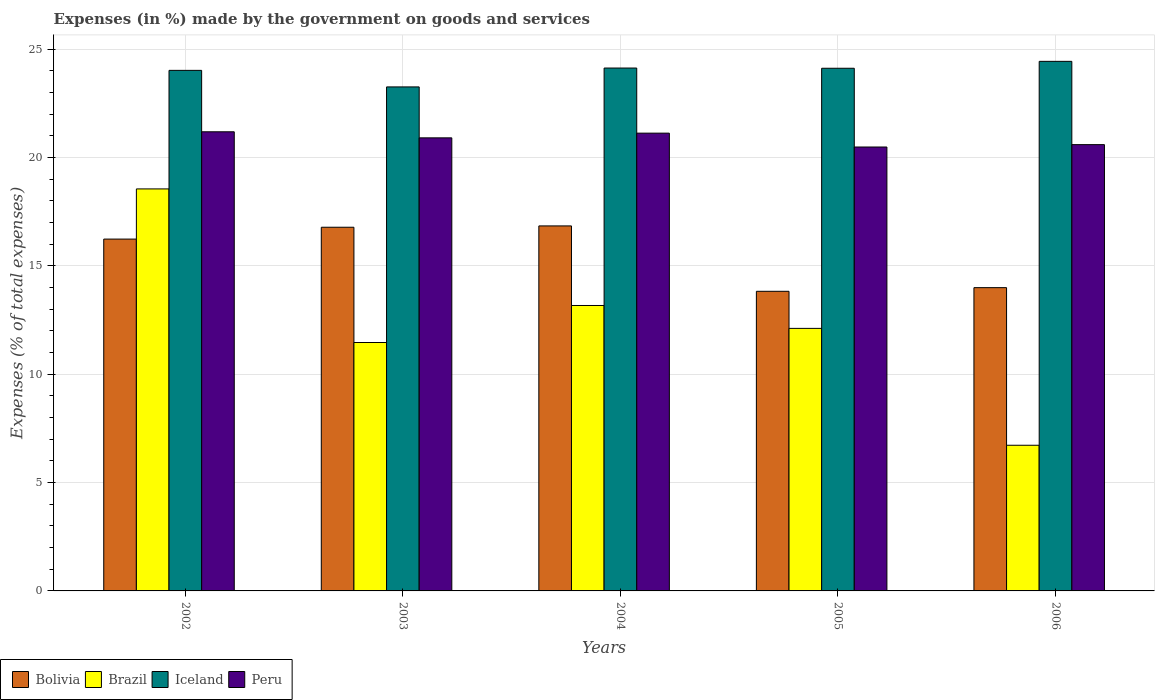Are the number of bars on each tick of the X-axis equal?
Offer a terse response. Yes. How many bars are there on the 4th tick from the left?
Your answer should be compact. 4. In how many cases, is the number of bars for a given year not equal to the number of legend labels?
Ensure brevity in your answer.  0. What is the percentage of expenses made by the government on goods and services in Bolivia in 2003?
Your answer should be very brief. 16.78. Across all years, what is the maximum percentage of expenses made by the government on goods and services in Peru?
Your response must be concise. 21.18. Across all years, what is the minimum percentage of expenses made by the government on goods and services in Peru?
Your answer should be very brief. 20.48. What is the total percentage of expenses made by the government on goods and services in Iceland in the graph?
Your answer should be very brief. 119.93. What is the difference between the percentage of expenses made by the government on goods and services in Brazil in 2002 and that in 2003?
Offer a very short reply. 7.09. What is the difference between the percentage of expenses made by the government on goods and services in Brazil in 2002 and the percentage of expenses made by the government on goods and services in Bolivia in 2004?
Make the answer very short. 1.71. What is the average percentage of expenses made by the government on goods and services in Bolivia per year?
Ensure brevity in your answer.  15.53. In the year 2004, what is the difference between the percentage of expenses made by the government on goods and services in Brazil and percentage of expenses made by the government on goods and services in Bolivia?
Give a very brief answer. -3.67. In how many years, is the percentage of expenses made by the government on goods and services in Brazil greater than 19 %?
Offer a very short reply. 0. What is the ratio of the percentage of expenses made by the government on goods and services in Brazil in 2002 to that in 2006?
Provide a short and direct response. 2.76. Is the difference between the percentage of expenses made by the government on goods and services in Brazil in 2003 and 2006 greater than the difference between the percentage of expenses made by the government on goods and services in Bolivia in 2003 and 2006?
Provide a succinct answer. Yes. What is the difference between the highest and the second highest percentage of expenses made by the government on goods and services in Bolivia?
Make the answer very short. 0.06. What is the difference between the highest and the lowest percentage of expenses made by the government on goods and services in Peru?
Make the answer very short. 0.7. Is it the case that in every year, the sum of the percentage of expenses made by the government on goods and services in Iceland and percentage of expenses made by the government on goods and services in Bolivia is greater than the sum of percentage of expenses made by the government on goods and services in Brazil and percentage of expenses made by the government on goods and services in Peru?
Ensure brevity in your answer.  Yes. What does the 2nd bar from the left in 2004 represents?
Give a very brief answer. Brazil. Is it the case that in every year, the sum of the percentage of expenses made by the government on goods and services in Peru and percentage of expenses made by the government on goods and services in Brazil is greater than the percentage of expenses made by the government on goods and services in Iceland?
Give a very brief answer. Yes. How many bars are there?
Ensure brevity in your answer.  20. Are all the bars in the graph horizontal?
Offer a very short reply. No. How many years are there in the graph?
Give a very brief answer. 5. Does the graph contain any zero values?
Your answer should be compact. No. Where does the legend appear in the graph?
Your answer should be compact. Bottom left. What is the title of the graph?
Offer a terse response. Expenses (in %) made by the government on goods and services. What is the label or title of the X-axis?
Ensure brevity in your answer.  Years. What is the label or title of the Y-axis?
Provide a short and direct response. Expenses (% of total expenses). What is the Expenses (% of total expenses) in Bolivia in 2002?
Your answer should be compact. 16.23. What is the Expenses (% of total expenses) of Brazil in 2002?
Offer a very short reply. 18.55. What is the Expenses (% of total expenses) in Iceland in 2002?
Make the answer very short. 24.01. What is the Expenses (% of total expenses) of Peru in 2002?
Your answer should be compact. 21.18. What is the Expenses (% of total expenses) of Bolivia in 2003?
Your answer should be compact. 16.78. What is the Expenses (% of total expenses) in Brazil in 2003?
Make the answer very short. 11.46. What is the Expenses (% of total expenses) in Iceland in 2003?
Your answer should be compact. 23.25. What is the Expenses (% of total expenses) in Peru in 2003?
Your answer should be very brief. 20.9. What is the Expenses (% of total expenses) in Bolivia in 2004?
Offer a very short reply. 16.84. What is the Expenses (% of total expenses) of Brazil in 2004?
Give a very brief answer. 13.17. What is the Expenses (% of total expenses) in Iceland in 2004?
Offer a very short reply. 24.12. What is the Expenses (% of total expenses) in Peru in 2004?
Ensure brevity in your answer.  21.12. What is the Expenses (% of total expenses) in Bolivia in 2005?
Offer a very short reply. 13.82. What is the Expenses (% of total expenses) in Brazil in 2005?
Your answer should be very brief. 12.11. What is the Expenses (% of total expenses) in Iceland in 2005?
Your answer should be compact. 24.11. What is the Expenses (% of total expenses) of Peru in 2005?
Your response must be concise. 20.48. What is the Expenses (% of total expenses) in Bolivia in 2006?
Make the answer very short. 13.99. What is the Expenses (% of total expenses) of Brazil in 2006?
Provide a succinct answer. 6.72. What is the Expenses (% of total expenses) of Iceland in 2006?
Make the answer very short. 24.43. What is the Expenses (% of total expenses) of Peru in 2006?
Your response must be concise. 20.59. Across all years, what is the maximum Expenses (% of total expenses) in Bolivia?
Keep it short and to the point. 16.84. Across all years, what is the maximum Expenses (% of total expenses) of Brazil?
Make the answer very short. 18.55. Across all years, what is the maximum Expenses (% of total expenses) in Iceland?
Keep it short and to the point. 24.43. Across all years, what is the maximum Expenses (% of total expenses) in Peru?
Provide a short and direct response. 21.18. Across all years, what is the minimum Expenses (% of total expenses) of Bolivia?
Ensure brevity in your answer.  13.82. Across all years, what is the minimum Expenses (% of total expenses) in Brazil?
Give a very brief answer. 6.72. Across all years, what is the minimum Expenses (% of total expenses) in Iceland?
Keep it short and to the point. 23.25. Across all years, what is the minimum Expenses (% of total expenses) of Peru?
Your answer should be compact. 20.48. What is the total Expenses (% of total expenses) of Bolivia in the graph?
Your answer should be very brief. 77.66. What is the total Expenses (% of total expenses) of Brazil in the graph?
Offer a very short reply. 62.01. What is the total Expenses (% of total expenses) of Iceland in the graph?
Ensure brevity in your answer.  119.93. What is the total Expenses (% of total expenses) of Peru in the graph?
Your answer should be very brief. 104.27. What is the difference between the Expenses (% of total expenses) in Bolivia in 2002 and that in 2003?
Offer a terse response. -0.55. What is the difference between the Expenses (% of total expenses) of Brazil in 2002 and that in 2003?
Give a very brief answer. 7.09. What is the difference between the Expenses (% of total expenses) of Iceland in 2002 and that in 2003?
Provide a succinct answer. 0.76. What is the difference between the Expenses (% of total expenses) of Peru in 2002 and that in 2003?
Ensure brevity in your answer.  0.28. What is the difference between the Expenses (% of total expenses) of Bolivia in 2002 and that in 2004?
Your answer should be very brief. -0.61. What is the difference between the Expenses (% of total expenses) of Brazil in 2002 and that in 2004?
Make the answer very short. 5.38. What is the difference between the Expenses (% of total expenses) in Iceland in 2002 and that in 2004?
Provide a succinct answer. -0.11. What is the difference between the Expenses (% of total expenses) in Peru in 2002 and that in 2004?
Keep it short and to the point. 0.06. What is the difference between the Expenses (% of total expenses) of Bolivia in 2002 and that in 2005?
Make the answer very short. 2.41. What is the difference between the Expenses (% of total expenses) in Brazil in 2002 and that in 2005?
Keep it short and to the point. 6.43. What is the difference between the Expenses (% of total expenses) of Iceland in 2002 and that in 2005?
Your response must be concise. -0.1. What is the difference between the Expenses (% of total expenses) of Peru in 2002 and that in 2005?
Give a very brief answer. 0.7. What is the difference between the Expenses (% of total expenses) of Bolivia in 2002 and that in 2006?
Keep it short and to the point. 2.24. What is the difference between the Expenses (% of total expenses) in Brazil in 2002 and that in 2006?
Ensure brevity in your answer.  11.83. What is the difference between the Expenses (% of total expenses) in Iceland in 2002 and that in 2006?
Ensure brevity in your answer.  -0.42. What is the difference between the Expenses (% of total expenses) in Peru in 2002 and that in 2006?
Provide a short and direct response. 0.59. What is the difference between the Expenses (% of total expenses) in Bolivia in 2003 and that in 2004?
Your answer should be very brief. -0.06. What is the difference between the Expenses (% of total expenses) of Brazil in 2003 and that in 2004?
Ensure brevity in your answer.  -1.71. What is the difference between the Expenses (% of total expenses) in Iceland in 2003 and that in 2004?
Provide a short and direct response. -0.87. What is the difference between the Expenses (% of total expenses) of Peru in 2003 and that in 2004?
Provide a succinct answer. -0.22. What is the difference between the Expenses (% of total expenses) of Bolivia in 2003 and that in 2005?
Provide a short and direct response. 2.96. What is the difference between the Expenses (% of total expenses) of Brazil in 2003 and that in 2005?
Provide a short and direct response. -0.65. What is the difference between the Expenses (% of total expenses) of Iceland in 2003 and that in 2005?
Make the answer very short. -0.86. What is the difference between the Expenses (% of total expenses) of Peru in 2003 and that in 2005?
Your response must be concise. 0.42. What is the difference between the Expenses (% of total expenses) in Bolivia in 2003 and that in 2006?
Make the answer very short. 2.79. What is the difference between the Expenses (% of total expenses) of Brazil in 2003 and that in 2006?
Your answer should be very brief. 4.74. What is the difference between the Expenses (% of total expenses) of Iceland in 2003 and that in 2006?
Your response must be concise. -1.18. What is the difference between the Expenses (% of total expenses) in Peru in 2003 and that in 2006?
Provide a succinct answer. 0.31. What is the difference between the Expenses (% of total expenses) in Bolivia in 2004 and that in 2005?
Ensure brevity in your answer.  3.02. What is the difference between the Expenses (% of total expenses) in Brazil in 2004 and that in 2005?
Offer a terse response. 1.06. What is the difference between the Expenses (% of total expenses) of Iceland in 2004 and that in 2005?
Provide a succinct answer. 0.01. What is the difference between the Expenses (% of total expenses) in Peru in 2004 and that in 2005?
Ensure brevity in your answer.  0.64. What is the difference between the Expenses (% of total expenses) in Bolivia in 2004 and that in 2006?
Provide a short and direct response. 2.85. What is the difference between the Expenses (% of total expenses) in Brazil in 2004 and that in 2006?
Your response must be concise. 6.45. What is the difference between the Expenses (% of total expenses) of Iceland in 2004 and that in 2006?
Provide a succinct answer. -0.31. What is the difference between the Expenses (% of total expenses) in Peru in 2004 and that in 2006?
Offer a very short reply. 0.53. What is the difference between the Expenses (% of total expenses) of Bolivia in 2005 and that in 2006?
Provide a succinct answer. -0.17. What is the difference between the Expenses (% of total expenses) in Brazil in 2005 and that in 2006?
Offer a very short reply. 5.39. What is the difference between the Expenses (% of total expenses) in Iceland in 2005 and that in 2006?
Your answer should be compact. -0.32. What is the difference between the Expenses (% of total expenses) in Peru in 2005 and that in 2006?
Your answer should be very brief. -0.11. What is the difference between the Expenses (% of total expenses) of Bolivia in 2002 and the Expenses (% of total expenses) of Brazil in 2003?
Keep it short and to the point. 4.77. What is the difference between the Expenses (% of total expenses) of Bolivia in 2002 and the Expenses (% of total expenses) of Iceland in 2003?
Offer a very short reply. -7.02. What is the difference between the Expenses (% of total expenses) of Bolivia in 2002 and the Expenses (% of total expenses) of Peru in 2003?
Offer a terse response. -4.67. What is the difference between the Expenses (% of total expenses) in Brazil in 2002 and the Expenses (% of total expenses) in Iceland in 2003?
Ensure brevity in your answer.  -4.71. What is the difference between the Expenses (% of total expenses) of Brazil in 2002 and the Expenses (% of total expenses) of Peru in 2003?
Provide a succinct answer. -2.36. What is the difference between the Expenses (% of total expenses) of Iceland in 2002 and the Expenses (% of total expenses) of Peru in 2003?
Give a very brief answer. 3.11. What is the difference between the Expenses (% of total expenses) of Bolivia in 2002 and the Expenses (% of total expenses) of Brazil in 2004?
Provide a succinct answer. 3.06. What is the difference between the Expenses (% of total expenses) of Bolivia in 2002 and the Expenses (% of total expenses) of Iceland in 2004?
Ensure brevity in your answer.  -7.89. What is the difference between the Expenses (% of total expenses) in Bolivia in 2002 and the Expenses (% of total expenses) in Peru in 2004?
Make the answer very short. -4.89. What is the difference between the Expenses (% of total expenses) in Brazil in 2002 and the Expenses (% of total expenses) in Iceland in 2004?
Your response must be concise. -5.58. What is the difference between the Expenses (% of total expenses) of Brazil in 2002 and the Expenses (% of total expenses) of Peru in 2004?
Offer a very short reply. -2.57. What is the difference between the Expenses (% of total expenses) in Iceland in 2002 and the Expenses (% of total expenses) in Peru in 2004?
Your answer should be compact. 2.9. What is the difference between the Expenses (% of total expenses) of Bolivia in 2002 and the Expenses (% of total expenses) of Brazil in 2005?
Give a very brief answer. 4.12. What is the difference between the Expenses (% of total expenses) in Bolivia in 2002 and the Expenses (% of total expenses) in Iceland in 2005?
Offer a terse response. -7.88. What is the difference between the Expenses (% of total expenses) in Bolivia in 2002 and the Expenses (% of total expenses) in Peru in 2005?
Offer a terse response. -4.25. What is the difference between the Expenses (% of total expenses) in Brazil in 2002 and the Expenses (% of total expenses) in Iceland in 2005?
Give a very brief answer. -5.57. What is the difference between the Expenses (% of total expenses) of Brazil in 2002 and the Expenses (% of total expenses) of Peru in 2005?
Give a very brief answer. -1.93. What is the difference between the Expenses (% of total expenses) in Iceland in 2002 and the Expenses (% of total expenses) in Peru in 2005?
Provide a succinct answer. 3.54. What is the difference between the Expenses (% of total expenses) in Bolivia in 2002 and the Expenses (% of total expenses) in Brazil in 2006?
Give a very brief answer. 9.51. What is the difference between the Expenses (% of total expenses) of Bolivia in 2002 and the Expenses (% of total expenses) of Iceland in 2006?
Your answer should be compact. -8.2. What is the difference between the Expenses (% of total expenses) of Bolivia in 2002 and the Expenses (% of total expenses) of Peru in 2006?
Ensure brevity in your answer.  -4.36. What is the difference between the Expenses (% of total expenses) in Brazil in 2002 and the Expenses (% of total expenses) in Iceland in 2006?
Your response must be concise. -5.89. What is the difference between the Expenses (% of total expenses) in Brazil in 2002 and the Expenses (% of total expenses) in Peru in 2006?
Your answer should be compact. -2.04. What is the difference between the Expenses (% of total expenses) of Iceland in 2002 and the Expenses (% of total expenses) of Peru in 2006?
Provide a succinct answer. 3.43. What is the difference between the Expenses (% of total expenses) of Bolivia in 2003 and the Expenses (% of total expenses) of Brazil in 2004?
Give a very brief answer. 3.61. What is the difference between the Expenses (% of total expenses) in Bolivia in 2003 and the Expenses (% of total expenses) in Iceland in 2004?
Give a very brief answer. -7.34. What is the difference between the Expenses (% of total expenses) of Bolivia in 2003 and the Expenses (% of total expenses) of Peru in 2004?
Provide a short and direct response. -4.34. What is the difference between the Expenses (% of total expenses) in Brazil in 2003 and the Expenses (% of total expenses) in Iceland in 2004?
Your answer should be very brief. -12.66. What is the difference between the Expenses (% of total expenses) in Brazil in 2003 and the Expenses (% of total expenses) in Peru in 2004?
Offer a terse response. -9.66. What is the difference between the Expenses (% of total expenses) in Iceland in 2003 and the Expenses (% of total expenses) in Peru in 2004?
Give a very brief answer. 2.13. What is the difference between the Expenses (% of total expenses) of Bolivia in 2003 and the Expenses (% of total expenses) of Brazil in 2005?
Ensure brevity in your answer.  4.67. What is the difference between the Expenses (% of total expenses) of Bolivia in 2003 and the Expenses (% of total expenses) of Iceland in 2005?
Keep it short and to the point. -7.33. What is the difference between the Expenses (% of total expenses) of Bolivia in 2003 and the Expenses (% of total expenses) of Peru in 2005?
Your answer should be very brief. -3.7. What is the difference between the Expenses (% of total expenses) in Brazil in 2003 and the Expenses (% of total expenses) in Iceland in 2005?
Keep it short and to the point. -12.65. What is the difference between the Expenses (% of total expenses) of Brazil in 2003 and the Expenses (% of total expenses) of Peru in 2005?
Give a very brief answer. -9.02. What is the difference between the Expenses (% of total expenses) of Iceland in 2003 and the Expenses (% of total expenses) of Peru in 2005?
Make the answer very short. 2.77. What is the difference between the Expenses (% of total expenses) in Bolivia in 2003 and the Expenses (% of total expenses) in Brazil in 2006?
Your answer should be very brief. 10.06. What is the difference between the Expenses (% of total expenses) of Bolivia in 2003 and the Expenses (% of total expenses) of Iceland in 2006?
Make the answer very short. -7.65. What is the difference between the Expenses (% of total expenses) in Bolivia in 2003 and the Expenses (% of total expenses) in Peru in 2006?
Give a very brief answer. -3.81. What is the difference between the Expenses (% of total expenses) in Brazil in 2003 and the Expenses (% of total expenses) in Iceland in 2006?
Your response must be concise. -12.97. What is the difference between the Expenses (% of total expenses) of Brazil in 2003 and the Expenses (% of total expenses) of Peru in 2006?
Your response must be concise. -9.13. What is the difference between the Expenses (% of total expenses) in Iceland in 2003 and the Expenses (% of total expenses) in Peru in 2006?
Offer a terse response. 2.66. What is the difference between the Expenses (% of total expenses) in Bolivia in 2004 and the Expenses (% of total expenses) in Brazil in 2005?
Offer a very short reply. 4.73. What is the difference between the Expenses (% of total expenses) in Bolivia in 2004 and the Expenses (% of total expenses) in Iceland in 2005?
Make the answer very short. -7.27. What is the difference between the Expenses (% of total expenses) of Bolivia in 2004 and the Expenses (% of total expenses) of Peru in 2005?
Provide a short and direct response. -3.64. What is the difference between the Expenses (% of total expenses) of Brazil in 2004 and the Expenses (% of total expenses) of Iceland in 2005?
Offer a very short reply. -10.94. What is the difference between the Expenses (% of total expenses) of Brazil in 2004 and the Expenses (% of total expenses) of Peru in 2005?
Make the answer very short. -7.31. What is the difference between the Expenses (% of total expenses) in Iceland in 2004 and the Expenses (% of total expenses) in Peru in 2005?
Give a very brief answer. 3.64. What is the difference between the Expenses (% of total expenses) of Bolivia in 2004 and the Expenses (% of total expenses) of Brazil in 2006?
Give a very brief answer. 10.12. What is the difference between the Expenses (% of total expenses) in Bolivia in 2004 and the Expenses (% of total expenses) in Iceland in 2006?
Your response must be concise. -7.59. What is the difference between the Expenses (% of total expenses) of Bolivia in 2004 and the Expenses (% of total expenses) of Peru in 2006?
Offer a very short reply. -3.75. What is the difference between the Expenses (% of total expenses) of Brazil in 2004 and the Expenses (% of total expenses) of Iceland in 2006?
Offer a terse response. -11.26. What is the difference between the Expenses (% of total expenses) in Brazil in 2004 and the Expenses (% of total expenses) in Peru in 2006?
Your answer should be compact. -7.42. What is the difference between the Expenses (% of total expenses) of Iceland in 2004 and the Expenses (% of total expenses) of Peru in 2006?
Your answer should be very brief. 3.53. What is the difference between the Expenses (% of total expenses) of Bolivia in 2005 and the Expenses (% of total expenses) of Brazil in 2006?
Offer a terse response. 7.1. What is the difference between the Expenses (% of total expenses) of Bolivia in 2005 and the Expenses (% of total expenses) of Iceland in 2006?
Ensure brevity in your answer.  -10.61. What is the difference between the Expenses (% of total expenses) of Bolivia in 2005 and the Expenses (% of total expenses) of Peru in 2006?
Give a very brief answer. -6.77. What is the difference between the Expenses (% of total expenses) of Brazil in 2005 and the Expenses (% of total expenses) of Iceland in 2006?
Offer a very short reply. -12.32. What is the difference between the Expenses (% of total expenses) in Brazil in 2005 and the Expenses (% of total expenses) in Peru in 2006?
Your response must be concise. -8.48. What is the difference between the Expenses (% of total expenses) of Iceland in 2005 and the Expenses (% of total expenses) of Peru in 2006?
Keep it short and to the point. 3.52. What is the average Expenses (% of total expenses) in Bolivia per year?
Ensure brevity in your answer.  15.53. What is the average Expenses (% of total expenses) in Brazil per year?
Make the answer very short. 12.4. What is the average Expenses (% of total expenses) of Iceland per year?
Give a very brief answer. 23.99. What is the average Expenses (% of total expenses) in Peru per year?
Provide a succinct answer. 20.85. In the year 2002, what is the difference between the Expenses (% of total expenses) of Bolivia and Expenses (% of total expenses) of Brazil?
Give a very brief answer. -2.31. In the year 2002, what is the difference between the Expenses (% of total expenses) in Bolivia and Expenses (% of total expenses) in Iceland?
Your answer should be very brief. -7.78. In the year 2002, what is the difference between the Expenses (% of total expenses) in Bolivia and Expenses (% of total expenses) in Peru?
Provide a succinct answer. -4.95. In the year 2002, what is the difference between the Expenses (% of total expenses) of Brazil and Expenses (% of total expenses) of Iceland?
Ensure brevity in your answer.  -5.47. In the year 2002, what is the difference between the Expenses (% of total expenses) of Brazil and Expenses (% of total expenses) of Peru?
Offer a terse response. -2.64. In the year 2002, what is the difference between the Expenses (% of total expenses) of Iceland and Expenses (% of total expenses) of Peru?
Make the answer very short. 2.83. In the year 2003, what is the difference between the Expenses (% of total expenses) in Bolivia and Expenses (% of total expenses) in Brazil?
Keep it short and to the point. 5.32. In the year 2003, what is the difference between the Expenses (% of total expenses) of Bolivia and Expenses (% of total expenses) of Iceland?
Your answer should be compact. -6.47. In the year 2003, what is the difference between the Expenses (% of total expenses) of Bolivia and Expenses (% of total expenses) of Peru?
Your response must be concise. -4.12. In the year 2003, what is the difference between the Expenses (% of total expenses) in Brazil and Expenses (% of total expenses) in Iceland?
Provide a short and direct response. -11.79. In the year 2003, what is the difference between the Expenses (% of total expenses) in Brazil and Expenses (% of total expenses) in Peru?
Your response must be concise. -9.44. In the year 2003, what is the difference between the Expenses (% of total expenses) of Iceland and Expenses (% of total expenses) of Peru?
Keep it short and to the point. 2.35. In the year 2004, what is the difference between the Expenses (% of total expenses) in Bolivia and Expenses (% of total expenses) in Brazil?
Keep it short and to the point. 3.67. In the year 2004, what is the difference between the Expenses (% of total expenses) in Bolivia and Expenses (% of total expenses) in Iceland?
Offer a very short reply. -7.28. In the year 2004, what is the difference between the Expenses (% of total expenses) of Bolivia and Expenses (% of total expenses) of Peru?
Your answer should be compact. -4.28. In the year 2004, what is the difference between the Expenses (% of total expenses) of Brazil and Expenses (% of total expenses) of Iceland?
Offer a very short reply. -10.96. In the year 2004, what is the difference between the Expenses (% of total expenses) of Brazil and Expenses (% of total expenses) of Peru?
Ensure brevity in your answer.  -7.95. In the year 2004, what is the difference between the Expenses (% of total expenses) in Iceland and Expenses (% of total expenses) in Peru?
Provide a succinct answer. 3. In the year 2005, what is the difference between the Expenses (% of total expenses) of Bolivia and Expenses (% of total expenses) of Brazil?
Offer a very short reply. 1.71. In the year 2005, what is the difference between the Expenses (% of total expenses) of Bolivia and Expenses (% of total expenses) of Iceland?
Your answer should be very brief. -10.29. In the year 2005, what is the difference between the Expenses (% of total expenses) of Bolivia and Expenses (% of total expenses) of Peru?
Offer a terse response. -6.66. In the year 2005, what is the difference between the Expenses (% of total expenses) in Brazil and Expenses (% of total expenses) in Iceland?
Offer a very short reply. -12. In the year 2005, what is the difference between the Expenses (% of total expenses) of Brazil and Expenses (% of total expenses) of Peru?
Make the answer very short. -8.37. In the year 2005, what is the difference between the Expenses (% of total expenses) of Iceland and Expenses (% of total expenses) of Peru?
Ensure brevity in your answer.  3.63. In the year 2006, what is the difference between the Expenses (% of total expenses) of Bolivia and Expenses (% of total expenses) of Brazil?
Provide a succinct answer. 7.27. In the year 2006, what is the difference between the Expenses (% of total expenses) of Bolivia and Expenses (% of total expenses) of Iceland?
Ensure brevity in your answer.  -10.44. In the year 2006, what is the difference between the Expenses (% of total expenses) of Bolivia and Expenses (% of total expenses) of Peru?
Keep it short and to the point. -6.6. In the year 2006, what is the difference between the Expenses (% of total expenses) in Brazil and Expenses (% of total expenses) in Iceland?
Your response must be concise. -17.71. In the year 2006, what is the difference between the Expenses (% of total expenses) of Brazil and Expenses (% of total expenses) of Peru?
Offer a terse response. -13.87. In the year 2006, what is the difference between the Expenses (% of total expenses) in Iceland and Expenses (% of total expenses) in Peru?
Your answer should be very brief. 3.84. What is the ratio of the Expenses (% of total expenses) in Bolivia in 2002 to that in 2003?
Make the answer very short. 0.97. What is the ratio of the Expenses (% of total expenses) in Brazil in 2002 to that in 2003?
Ensure brevity in your answer.  1.62. What is the ratio of the Expenses (% of total expenses) in Iceland in 2002 to that in 2003?
Give a very brief answer. 1.03. What is the ratio of the Expenses (% of total expenses) of Peru in 2002 to that in 2003?
Offer a very short reply. 1.01. What is the ratio of the Expenses (% of total expenses) of Bolivia in 2002 to that in 2004?
Your answer should be compact. 0.96. What is the ratio of the Expenses (% of total expenses) of Brazil in 2002 to that in 2004?
Offer a very short reply. 1.41. What is the ratio of the Expenses (% of total expenses) in Peru in 2002 to that in 2004?
Your answer should be very brief. 1. What is the ratio of the Expenses (% of total expenses) of Bolivia in 2002 to that in 2005?
Your answer should be compact. 1.17. What is the ratio of the Expenses (% of total expenses) in Brazil in 2002 to that in 2005?
Your answer should be compact. 1.53. What is the ratio of the Expenses (% of total expenses) of Peru in 2002 to that in 2005?
Give a very brief answer. 1.03. What is the ratio of the Expenses (% of total expenses) in Bolivia in 2002 to that in 2006?
Your response must be concise. 1.16. What is the ratio of the Expenses (% of total expenses) of Brazil in 2002 to that in 2006?
Offer a very short reply. 2.76. What is the ratio of the Expenses (% of total expenses) of Iceland in 2002 to that in 2006?
Your answer should be compact. 0.98. What is the ratio of the Expenses (% of total expenses) in Peru in 2002 to that in 2006?
Offer a very short reply. 1.03. What is the ratio of the Expenses (% of total expenses) in Brazil in 2003 to that in 2004?
Make the answer very short. 0.87. What is the ratio of the Expenses (% of total expenses) in Iceland in 2003 to that in 2004?
Your answer should be very brief. 0.96. What is the ratio of the Expenses (% of total expenses) of Peru in 2003 to that in 2004?
Give a very brief answer. 0.99. What is the ratio of the Expenses (% of total expenses) in Bolivia in 2003 to that in 2005?
Keep it short and to the point. 1.21. What is the ratio of the Expenses (% of total expenses) of Brazil in 2003 to that in 2005?
Make the answer very short. 0.95. What is the ratio of the Expenses (% of total expenses) of Iceland in 2003 to that in 2005?
Ensure brevity in your answer.  0.96. What is the ratio of the Expenses (% of total expenses) of Peru in 2003 to that in 2005?
Your answer should be very brief. 1.02. What is the ratio of the Expenses (% of total expenses) in Bolivia in 2003 to that in 2006?
Offer a very short reply. 1.2. What is the ratio of the Expenses (% of total expenses) in Brazil in 2003 to that in 2006?
Your answer should be very brief. 1.71. What is the ratio of the Expenses (% of total expenses) in Iceland in 2003 to that in 2006?
Offer a terse response. 0.95. What is the ratio of the Expenses (% of total expenses) of Peru in 2003 to that in 2006?
Provide a short and direct response. 1.02. What is the ratio of the Expenses (% of total expenses) of Bolivia in 2004 to that in 2005?
Keep it short and to the point. 1.22. What is the ratio of the Expenses (% of total expenses) in Brazil in 2004 to that in 2005?
Provide a short and direct response. 1.09. What is the ratio of the Expenses (% of total expenses) of Peru in 2004 to that in 2005?
Your answer should be very brief. 1.03. What is the ratio of the Expenses (% of total expenses) in Bolivia in 2004 to that in 2006?
Offer a very short reply. 1.2. What is the ratio of the Expenses (% of total expenses) in Brazil in 2004 to that in 2006?
Ensure brevity in your answer.  1.96. What is the ratio of the Expenses (% of total expenses) of Iceland in 2004 to that in 2006?
Your answer should be compact. 0.99. What is the ratio of the Expenses (% of total expenses) of Peru in 2004 to that in 2006?
Your response must be concise. 1.03. What is the ratio of the Expenses (% of total expenses) of Brazil in 2005 to that in 2006?
Your answer should be compact. 1.8. What is the difference between the highest and the second highest Expenses (% of total expenses) of Bolivia?
Provide a short and direct response. 0.06. What is the difference between the highest and the second highest Expenses (% of total expenses) in Brazil?
Your response must be concise. 5.38. What is the difference between the highest and the second highest Expenses (% of total expenses) of Iceland?
Keep it short and to the point. 0.31. What is the difference between the highest and the second highest Expenses (% of total expenses) of Peru?
Ensure brevity in your answer.  0.06. What is the difference between the highest and the lowest Expenses (% of total expenses) of Bolivia?
Ensure brevity in your answer.  3.02. What is the difference between the highest and the lowest Expenses (% of total expenses) in Brazil?
Your response must be concise. 11.83. What is the difference between the highest and the lowest Expenses (% of total expenses) of Iceland?
Offer a terse response. 1.18. What is the difference between the highest and the lowest Expenses (% of total expenses) in Peru?
Your answer should be very brief. 0.7. 